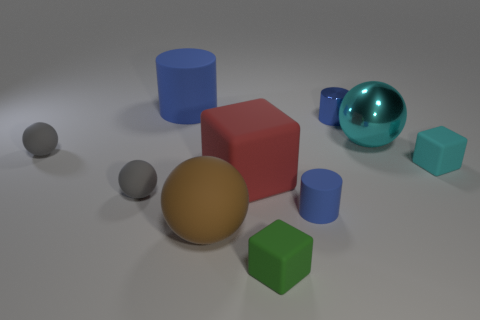Subtract 1 spheres. How many spheres are left? 3 Subtract all brown balls. How many balls are left? 3 Subtract all cyan spheres. How many spheres are left? 3 Subtract all blue spheres. Subtract all green cylinders. How many spheres are left? 4 Subtract all cylinders. How many objects are left? 7 Subtract 1 cyan cubes. How many objects are left? 9 Subtract all big brown matte objects. Subtract all big brown balls. How many objects are left? 8 Add 1 tiny matte cubes. How many tiny matte cubes are left? 3 Add 7 red matte cubes. How many red matte cubes exist? 8 